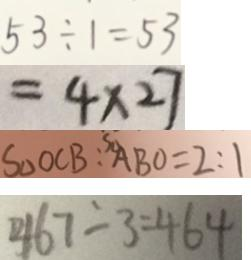<formula> <loc_0><loc_0><loc_500><loc_500>5 3 \div 1 = 5 3 
 = 4 \times 2 7 
 S _ { \Delta } O C B : ^ { S _ { \Delta } } A B O = 2 : 1 
 4 6 7 - 3 = 4 6 4</formula> 